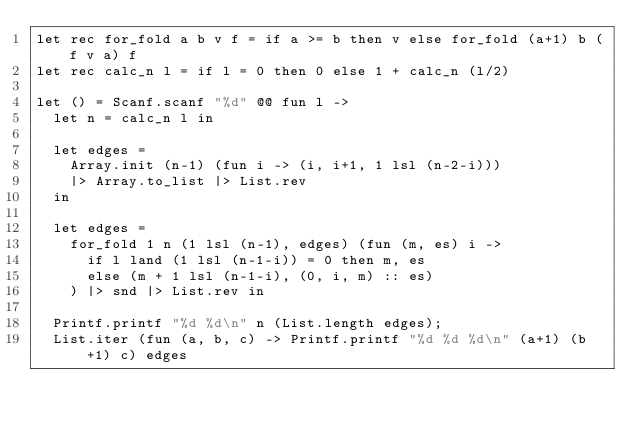Convert code to text. <code><loc_0><loc_0><loc_500><loc_500><_OCaml_>let rec for_fold a b v f = if a >= b then v else for_fold (a+1) b (f v a) f
let rec calc_n l = if l = 0 then 0 else 1 + calc_n (l/2)

let () = Scanf.scanf "%d" @@ fun l ->
  let n = calc_n l in

  let edges =
    Array.init (n-1) (fun i -> (i, i+1, 1 lsl (n-2-i)))
    |> Array.to_list |> List.rev
  in

  let edges =
    for_fold 1 n (1 lsl (n-1), edges) (fun (m, es) i ->
      if l land (1 lsl (n-1-i)) = 0 then m, es
      else (m + 1 lsl (n-1-i), (0, i, m) :: es)
    ) |> snd |> List.rev in

  Printf.printf "%d %d\n" n (List.length edges);
  List.iter (fun (a, b, c) -> Printf.printf "%d %d %d\n" (a+1) (b+1) c) edges</code> 